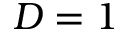<formula> <loc_0><loc_0><loc_500><loc_500>D = 1</formula> 